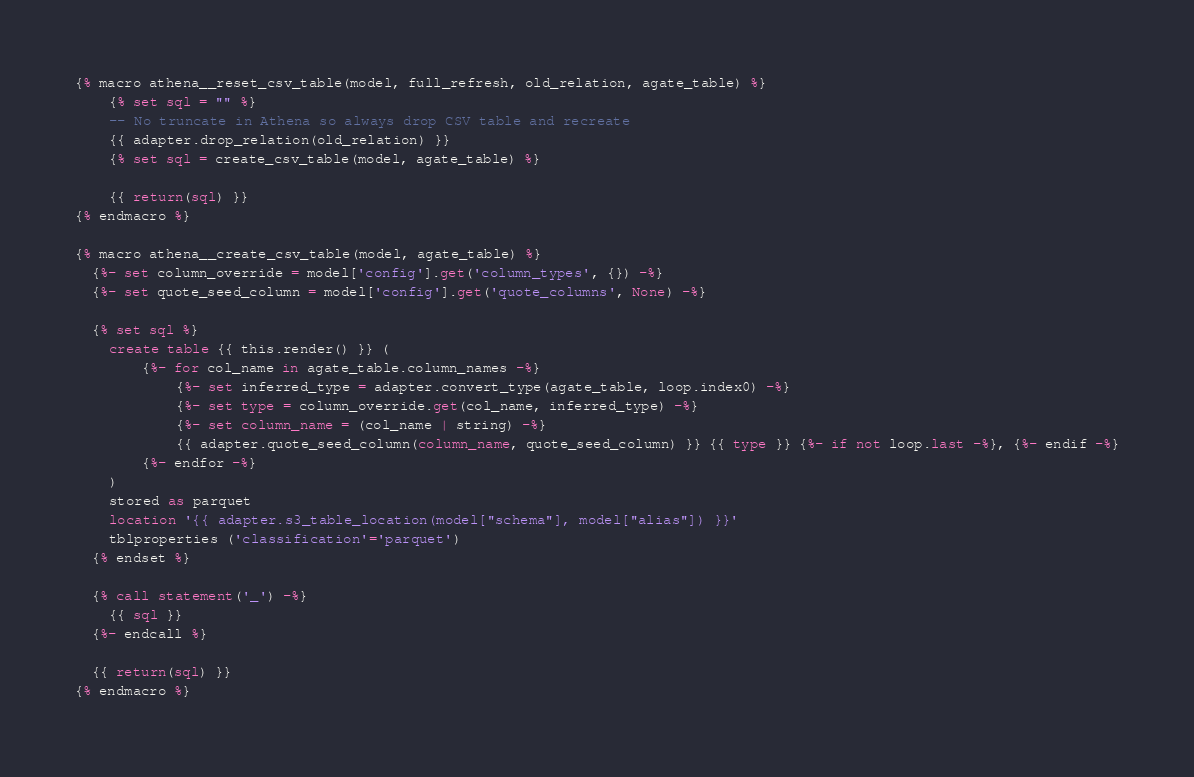Convert code to text. <code><loc_0><loc_0><loc_500><loc_500><_SQL_>{% macro athena__reset_csv_table(model, full_refresh, old_relation, agate_table) %}
    {% set sql = "" %}
    -- No truncate in Athena so always drop CSV table and recreate
    {{ adapter.drop_relation(old_relation) }}
    {% set sql = create_csv_table(model, agate_table) %}

    {{ return(sql) }}
{% endmacro %}

{% macro athena__create_csv_table(model, agate_table) %} 
  {%- set column_override = model['config'].get('column_types', {}) -%}
  {%- set quote_seed_column = model['config'].get('quote_columns', None) -%}

  {% set sql %}
    create table {{ this.render() }} (
        {%- for col_name in agate_table.column_names -%}
            {%- set inferred_type = adapter.convert_type(agate_table, loop.index0) -%}
            {%- set type = column_override.get(col_name, inferred_type) -%}
            {%- set column_name = (col_name | string) -%}
            {{ adapter.quote_seed_column(column_name, quote_seed_column) }} {{ type }} {%- if not loop.last -%}, {%- endif -%}
        {%- endfor -%}
    )
    stored as parquet
    location '{{ adapter.s3_table_location(model["schema"], model["alias"]) }}'
    tblproperties ('classification'='parquet')
  {% endset %}

  {% call statement('_') -%}
    {{ sql }}
  {%- endcall %}

  {{ return(sql) }}
{% endmacro %}
</code> 